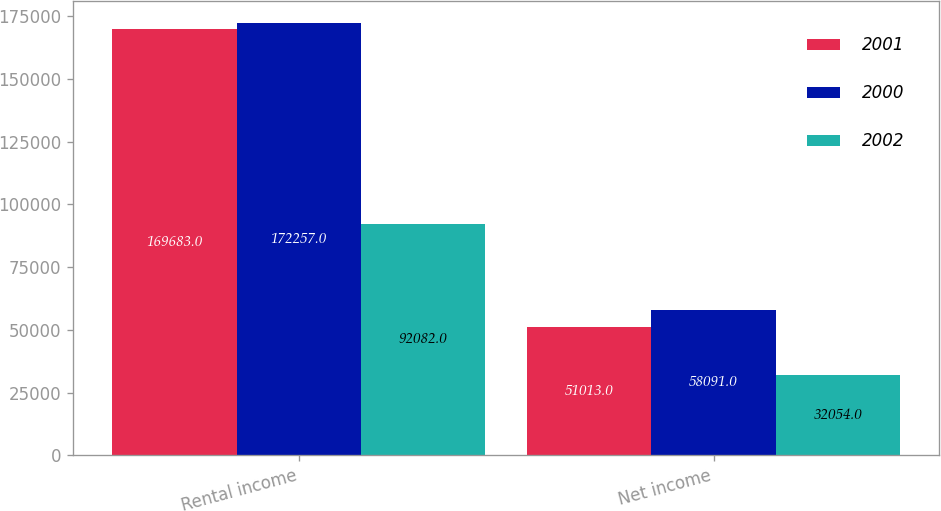Convert chart to OTSL. <chart><loc_0><loc_0><loc_500><loc_500><stacked_bar_chart><ecel><fcel>Rental income<fcel>Net income<nl><fcel>2001<fcel>169683<fcel>51013<nl><fcel>2000<fcel>172257<fcel>58091<nl><fcel>2002<fcel>92082<fcel>32054<nl></chart> 